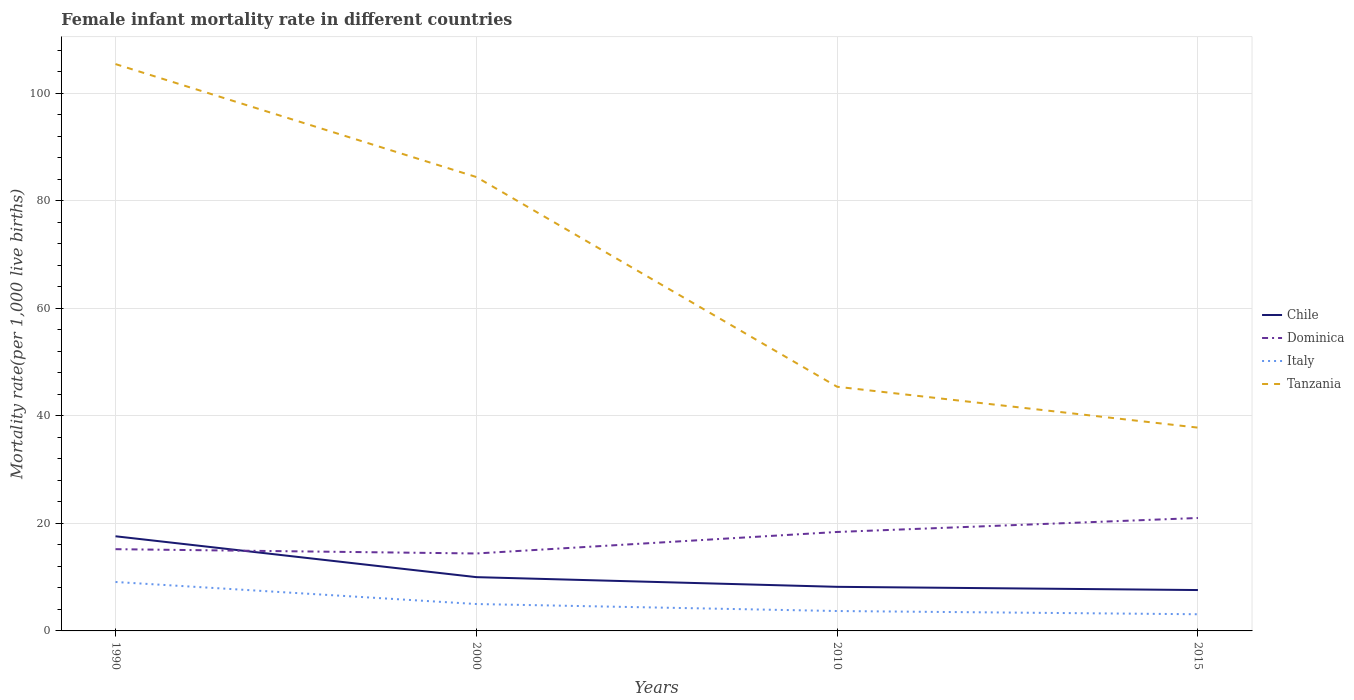In which year was the female infant mortality rate in Tanzania maximum?
Ensure brevity in your answer.  2015. What is the total female infant mortality rate in Dominica in the graph?
Provide a short and direct response. -5.8. What is the difference between the highest and the second highest female infant mortality rate in Dominica?
Make the answer very short. 6.6. How many lines are there?
Provide a succinct answer. 4. How many years are there in the graph?
Provide a short and direct response. 4. Are the values on the major ticks of Y-axis written in scientific E-notation?
Offer a terse response. No. Does the graph contain any zero values?
Provide a short and direct response. No. How are the legend labels stacked?
Keep it short and to the point. Vertical. What is the title of the graph?
Your answer should be very brief. Female infant mortality rate in different countries. Does "St. Kitts and Nevis" appear as one of the legend labels in the graph?
Make the answer very short. No. What is the label or title of the Y-axis?
Your answer should be compact. Mortality rate(per 1,0 live births). What is the Mortality rate(per 1,000 live births) in Chile in 1990?
Ensure brevity in your answer.  17.6. What is the Mortality rate(per 1,000 live births) of Italy in 1990?
Your response must be concise. 9.1. What is the Mortality rate(per 1,000 live births) in Tanzania in 1990?
Ensure brevity in your answer.  105.4. What is the Mortality rate(per 1,000 live births) of Chile in 2000?
Offer a very short reply. 10. What is the Mortality rate(per 1,000 live births) in Italy in 2000?
Your response must be concise. 5. What is the Mortality rate(per 1,000 live births) of Tanzania in 2000?
Provide a succinct answer. 84.4. What is the Mortality rate(per 1,000 live births) of Chile in 2010?
Your response must be concise. 8.2. What is the Mortality rate(per 1,000 live births) in Dominica in 2010?
Provide a short and direct response. 18.4. What is the Mortality rate(per 1,000 live births) in Italy in 2010?
Offer a very short reply. 3.7. What is the Mortality rate(per 1,000 live births) in Tanzania in 2010?
Offer a very short reply. 45.4. What is the Mortality rate(per 1,000 live births) in Chile in 2015?
Provide a short and direct response. 7.6. What is the Mortality rate(per 1,000 live births) of Tanzania in 2015?
Provide a succinct answer. 37.8. Across all years, what is the maximum Mortality rate(per 1,000 live births) of Chile?
Provide a short and direct response. 17.6. Across all years, what is the maximum Mortality rate(per 1,000 live births) in Tanzania?
Give a very brief answer. 105.4. Across all years, what is the minimum Mortality rate(per 1,000 live births) of Dominica?
Offer a very short reply. 14.4. Across all years, what is the minimum Mortality rate(per 1,000 live births) of Italy?
Keep it short and to the point. 3.1. Across all years, what is the minimum Mortality rate(per 1,000 live births) of Tanzania?
Make the answer very short. 37.8. What is the total Mortality rate(per 1,000 live births) in Chile in the graph?
Offer a terse response. 43.4. What is the total Mortality rate(per 1,000 live births) in Italy in the graph?
Provide a short and direct response. 20.9. What is the total Mortality rate(per 1,000 live births) in Tanzania in the graph?
Offer a terse response. 273. What is the difference between the Mortality rate(per 1,000 live births) in Dominica in 1990 and that in 2000?
Ensure brevity in your answer.  0.8. What is the difference between the Mortality rate(per 1,000 live births) in Italy in 1990 and that in 2000?
Provide a short and direct response. 4.1. What is the difference between the Mortality rate(per 1,000 live births) in Tanzania in 1990 and that in 2010?
Make the answer very short. 60. What is the difference between the Mortality rate(per 1,000 live births) of Chile in 1990 and that in 2015?
Ensure brevity in your answer.  10. What is the difference between the Mortality rate(per 1,000 live births) of Dominica in 1990 and that in 2015?
Offer a terse response. -5.8. What is the difference between the Mortality rate(per 1,000 live births) of Tanzania in 1990 and that in 2015?
Keep it short and to the point. 67.6. What is the difference between the Mortality rate(per 1,000 live births) of Dominica in 2000 and that in 2010?
Provide a short and direct response. -4. What is the difference between the Mortality rate(per 1,000 live births) in Italy in 2000 and that in 2010?
Your answer should be very brief. 1.3. What is the difference between the Mortality rate(per 1,000 live births) of Tanzania in 2000 and that in 2010?
Give a very brief answer. 39. What is the difference between the Mortality rate(per 1,000 live births) in Chile in 2000 and that in 2015?
Give a very brief answer. 2.4. What is the difference between the Mortality rate(per 1,000 live births) in Dominica in 2000 and that in 2015?
Your response must be concise. -6.6. What is the difference between the Mortality rate(per 1,000 live births) of Tanzania in 2000 and that in 2015?
Offer a very short reply. 46.6. What is the difference between the Mortality rate(per 1,000 live births) in Chile in 2010 and that in 2015?
Ensure brevity in your answer.  0.6. What is the difference between the Mortality rate(per 1,000 live births) of Italy in 2010 and that in 2015?
Give a very brief answer. 0.6. What is the difference between the Mortality rate(per 1,000 live births) in Chile in 1990 and the Mortality rate(per 1,000 live births) in Tanzania in 2000?
Ensure brevity in your answer.  -66.8. What is the difference between the Mortality rate(per 1,000 live births) of Dominica in 1990 and the Mortality rate(per 1,000 live births) of Italy in 2000?
Give a very brief answer. 10.2. What is the difference between the Mortality rate(per 1,000 live births) of Dominica in 1990 and the Mortality rate(per 1,000 live births) of Tanzania in 2000?
Offer a terse response. -69.2. What is the difference between the Mortality rate(per 1,000 live births) of Italy in 1990 and the Mortality rate(per 1,000 live births) of Tanzania in 2000?
Offer a very short reply. -75.3. What is the difference between the Mortality rate(per 1,000 live births) in Chile in 1990 and the Mortality rate(per 1,000 live births) in Tanzania in 2010?
Your answer should be compact. -27.8. What is the difference between the Mortality rate(per 1,000 live births) of Dominica in 1990 and the Mortality rate(per 1,000 live births) of Tanzania in 2010?
Offer a terse response. -30.2. What is the difference between the Mortality rate(per 1,000 live births) in Italy in 1990 and the Mortality rate(per 1,000 live births) in Tanzania in 2010?
Provide a short and direct response. -36.3. What is the difference between the Mortality rate(per 1,000 live births) in Chile in 1990 and the Mortality rate(per 1,000 live births) in Italy in 2015?
Offer a terse response. 14.5. What is the difference between the Mortality rate(per 1,000 live births) in Chile in 1990 and the Mortality rate(per 1,000 live births) in Tanzania in 2015?
Make the answer very short. -20.2. What is the difference between the Mortality rate(per 1,000 live births) in Dominica in 1990 and the Mortality rate(per 1,000 live births) in Tanzania in 2015?
Offer a very short reply. -22.6. What is the difference between the Mortality rate(per 1,000 live births) in Italy in 1990 and the Mortality rate(per 1,000 live births) in Tanzania in 2015?
Your response must be concise. -28.7. What is the difference between the Mortality rate(per 1,000 live births) of Chile in 2000 and the Mortality rate(per 1,000 live births) of Dominica in 2010?
Provide a short and direct response. -8.4. What is the difference between the Mortality rate(per 1,000 live births) in Chile in 2000 and the Mortality rate(per 1,000 live births) in Tanzania in 2010?
Provide a short and direct response. -35.4. What is the difference between the Mortality rate(per 1,000 live births) of Dominica in 2000 and the Mortality rate(per 1,000 live births) of Tanzania in 2010?
Your answer should be compact. -31. What is the difference between the Mortality rate(per 1,000 live births) of Italy in 2000 and the Mortality rate(per 1,000 live births) of Tanzania in 2010?
Your answer should be very brief. -40.4. What is the difference between the Mortality rate(per 1,000 live births) of Chile in 2000 and the Mortality rate(per 1,000 live births) of Italy in 2015?
Your answer should be very brief. 6.9. What is the difference between the Mortality rate(per 1,000 live births) of Chile in 2000 and the Mortality rate(per 1,000 live births) of Tanzania in 2015?
Your answer should be compact. -27.8. What is the difference between the Mortality rate(per 1,000 live births) in Dominica in 2000 and the Mortality rate(per 1,000 live births) in Italy in 2015?
Keep it short and to the point. 11.3. What is the difference between the Mortality rate(per 1,000 live births) in Dominica in 2000 and the Mortality rate(per 1,000 live births) in Tanzania in 2015?
Ensure brevity in your answer.  -23.4. What is the difference between the Mortality rate(per 1,000 live births) of Italy in 2000 and the Mortality rate(per 1,000 live births) of Tanzania in 2015?
Provide a succinct answer. -32.8. What is the difference between the Mortality rate(per 1,000 live births) of Chile in 2010 and the Mortality rate(per 1,000 live births) of Italy in 2015?
Offer a very short reply. 5.1. What is the difference between the Mortality rate(per 1,000 live births) of Chile in 2010 and the Mortality rate(per 1,000 live births) of Tanzania in 2015?
Your answer should be very brief. -29.6. What is the difference between the Mortality rate(per 1,000 live births) in Dominica in 2010 and the Mortality rate(per 1,000 live births) in Tanzania in 2015?
Give a very brief answer. -19.4. What is the difference between the Mortality rate(per 1,000 live births) in Italy in 2010 and the Mortality rate(per 1,000 live births) in Tanzania in 2015?
Your response must be concise. -34.1. What is the average Mortality rate(per 1,000 live births) of Chile per year?
Your answer should be compact. 10.85. What is the average Mortality rate(per 1,000 live births) of Dominica per year?
Your response must be concise. 17.25. What is the average Mortality rate(per 1,000 live births) of Italy per year?
Offer a terse response. 5.22. What is the average Mortality rate(per 1,000 live births) in Tanzania per year?
Ensure brevity in your answer.  68.25. In the year 1990, what is the difference between the Mortality rate(per 1,000 live births) of Chile and Mortality rate(per 1,000 live births) of Tanzania?
Ensure brevity in your answer.  -87.8. In the year 1990, what is the difference between the Mortality rate(per 1,000 live births) of Dominica and Mortality rate(per 1,000 live births) of Italy?
Keep it short and to the point. 6.1. In the year 1990, what is the difference between the Mortality rate(per 1,000 live births) in Dominica and Mortality rate(per 1,000 live births) in Tanzania?
Offer a very short reply. -90.2. In the year 1990, what is the difference between the Mortality rate(per 1,000 live births) of Italy and Mortality rate(per 1,000 live births) of Tanzania?
Make the answer very short. -96.3. In the year 2000, what is the difference between the Mortality rate(per 1,000 live births) of Chile and Mortality rate(per 1,000 live births) of Tanzania?
Ensure brevity in your answer.  -74.4. In the year 2000, what is the difference between the Mortality rate(per 1,000 live births) of Dominica and Mortality rate(per 1,000 live births) of Italy?
Your answer should be very brief. 9.4. In the year 2000, what is the difference between the Mortality rate(per 1,000 live births) in Dominica and Mortality rate(per 1,000 live births) in Tanzania?
Offer a very short reply. -70. In the year 2000, what is the difference between the Mortality rate(per 1,000 live births) of Italy and Mortality rate(per 1,000 live births) of Tanzania?
Your answer should be compact. -79.4. In the year 2010, what is the difference between the Mortality rate(per 1,000 live births) of Chile and Mortality rate(per 1,000 live births) of Tanzania?
Offer a terse response. -37.2. In the year 2010, what is the difference between the Mortality rate(per 1,000 live births) of Dominica and Mortality rate(per 1,000 live births) of Tanzania?
Offer a very short reply. -27. In the year 2010, what is the difference between the Mortality rate(per 1,000 live births) in Italy and Mortality rate(per 1,000 live births) in Tanzania?
Provide a short and direct response. -41.7. In the year 2015, what is the difference between the Mortality rate(per 1,000 live births) in Chile and Mortality rate(per 1,000 live births) in Tanzania?
Offer a terse response. -30.2. In the year 2015, what is the difference between the Mortality rate(per 1,000 live births) in Dominica and Mortality rate(per 1,000 live births) in Italy?
Make the answer very short. 17.9. In the year 2015, what is the difference between the Mortality rate(per 1,000 live births) in Dominica and Mortality rate(per 1,000 live births) in Tanzania?
Give a very brief answer. -16.8. In the year 2015, what is the difference between the Mortality rate(per 1,000 live births) of Italy and Mortality rate(per 1,000 live births) of Tanzania?
Provide a succinct answer. -34.7. What is the ratio of the Mortality rate(per 1,000 live births) in Chile in 1990 to that in 2000?
Ensure brevity in your answer.  1.76. What is the ratio of the Mortality rate(per 1,000 live births) of Dominica in 1990 to that in 2000?
Your answer should be compact. 1.06. What is the ratio of the Mortality rate(per 1,000 live births) of Italy in 1990 to that in 2000?
Provide a succinct answer. 1.82. What is the ratio of the Mortality rate(per 1,000 live births) in Tanzania in 1990 to that in 2000?
Provide a succinct answer. 1.25. What is the ratio of the Mortality rate(per 1,000 live births) of Chile in 1990 to that in 2010?
Keep it short and to the point. 2.15. What is the ratio of the Mortality rate(per 1,000 live births) in Dominica in 1990 to that in 2010?
Your answer should be very brief. 0.83. What is the ratio of the Mortality rate(per 1,000 live births) in Italy in 1990 to that in 2010?
Provide a succinct answer. 2.46. What is the ratio of the Mortality rate(per 1,000 live births) of Tanzania in 1990 to that in 2010?
Provide a short and direct response. 2.32. What is the ratio of the Mortality rate(per 1,000 live births) of Chile in 1990 to that in 2015?
Your answer should be compact. 2.32. What is the ratio of the Mortality rate(per 1,000 live births) of Dominica in 1990 to that in 2015?
Keep it short and to the point. 0.72. What is the ratio of the Mortality rate(per 1,000 live births) in Italy in 1990 to that in 2015?
Give a very brief answer. 2.94. What is the ratio of the Mortality rate(per 1,000 live births) of Tanzania in 1990 to that in 2015?
Your answer should be very brief. 2.79. What is the ratio of the Mortality rate(per 1,000 live births) in Chile in 2000 to that in 2010?
Make the answer very short. 1.22. What is the ratio of the Mortality rate(per 1,000 live births) of Dominica in 2000 to that in 2010?
Ensure brevity in your answer.  0.78. What is the ratio of the Mortality rate(per 1,000 live births) of Italy in 2000 to that in 2010?
Offer a terse response. 1.35. What is the ratio of the Mortality rate(per 1,000 live births) of Tanzania in 2000 to that in 2010?
Your response must be concise. 1.86. What is the ratio of the Mortality rate(per 1,000 live births) of Chile in 2000 to that in 2015?
Make the answer very short. 1.32. What is the ratio of the Mortality rate(per 1,000 live births) in Dominica in 2000 to that in 2015?
Keep it short and to the point. 0.69. What is the ratio of the Mortality rate(per 1,000 live births) of Italy in 2000 to that in 2015?
Give a very brief answer. 1.61. What is the ratio of the Mortality rate(per 1,000 live births) of Tanzania in 2000 to that in 2015?
Your answer should be compact. 2.23. What is the ratio of the Mortality rate(per 1,000 live births) in Chile in 2010 to that in 2015?
Your answer should be very brief. 1.08. What is the ratio of the Mortality rate(per 1,000 live births) of Dominica in 2010 to that in 2015?
Offer a terse response. 0.88. What is the ratio of the Mortality rate(per 1,000 live births) in Italy in 2010 to that in 2015?
Keep it short and to the point. 1.19. What is the ratio of the Mortality rate(per 1,000 live births) of Tanzania in 2010 to that in 2015?
Provide a short and direct response. 1.2. What is the difference between the highest and the second highest Mortality rate(per 1,000 live births) in Chile?
Your response must be concise. 7.6. What is the difference between the highest and the lowest Mortality rate(per 1,000 live births) in Dominica?
Your answer should be compact. 6.6. What is the difference between the highest and the lowest Mortality rate(per 1,000 live births) in Tanzania?
Your response must be concise. 67.6. 